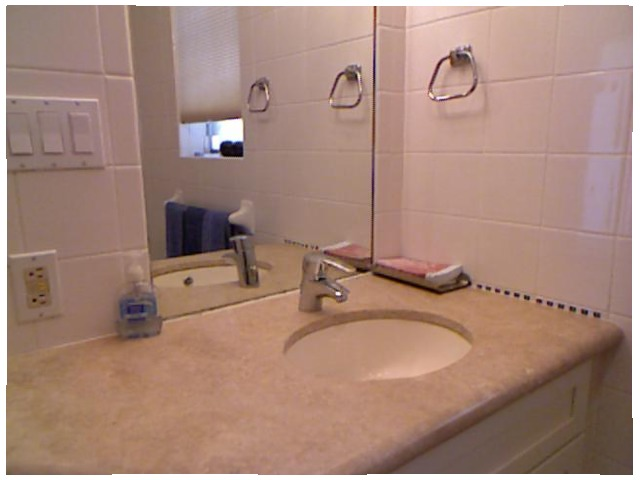<image>
Is the faucet to the right of the outlet? Yes. From this viewpoint, the faucet is positioned to the right side relative to the outlet. Is there a tap to the right of the liquid? Yes. From this viewpoint, the tap is positioned to the right side relative to the liquid. Is the handle in the mirror? Yes. The handle is contained within or inside the mirror, showing a containment relationship. Where is the napkin in relation to the sink? Is it in the sink? No. The napkin is not contained within the sink. These objects have a different spatial relationship. 